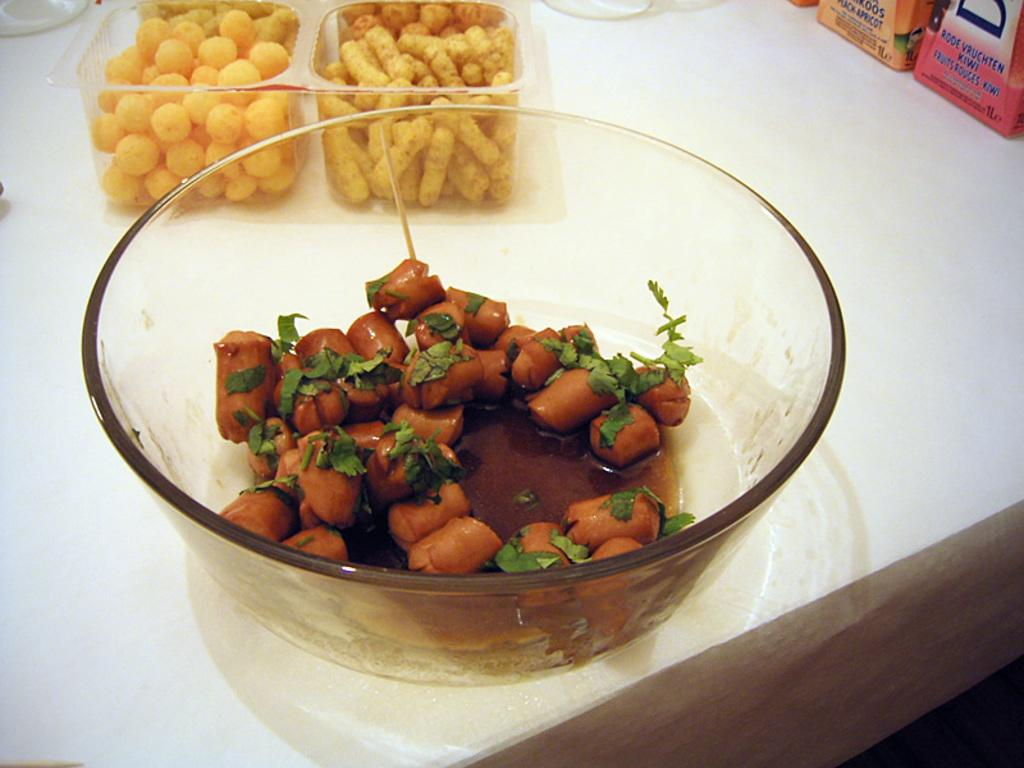How many bowls can be seen in the image? There are three bowls visible in the image. What is inside the bowls? The bowls contain food items. Where are the bowls located? The bowls are placed on a table. What else can be seen on the table? There are two packets on the table. How does the table regret its decision to hold the bowls in the image? Tables do not have the ability to feel regret or make decisions, so this question does not apply to the image. 